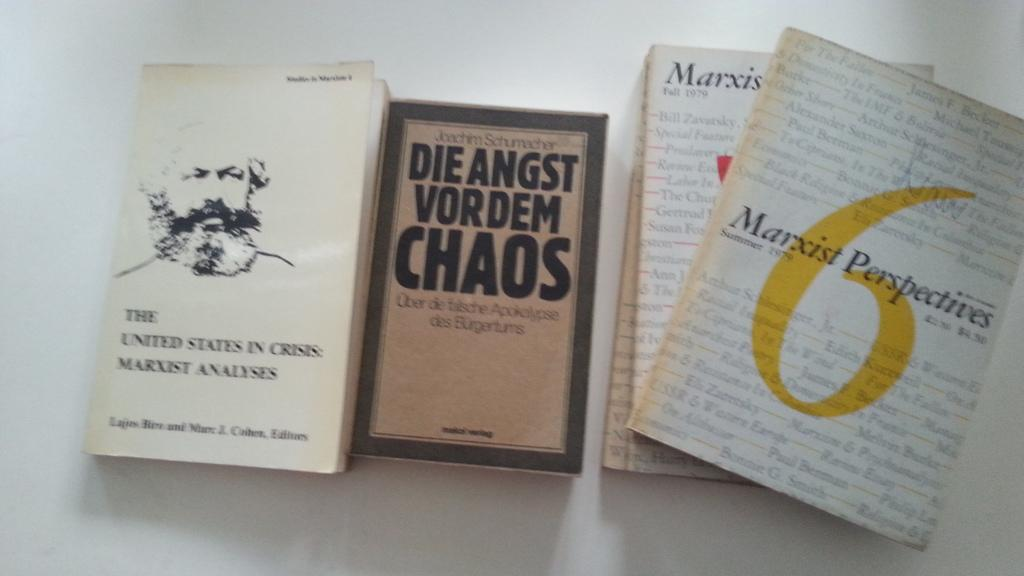<image>
Render a clear and concise summary of the photo. Die Angst Vordem Chaos and Marxist Perspectives books. 